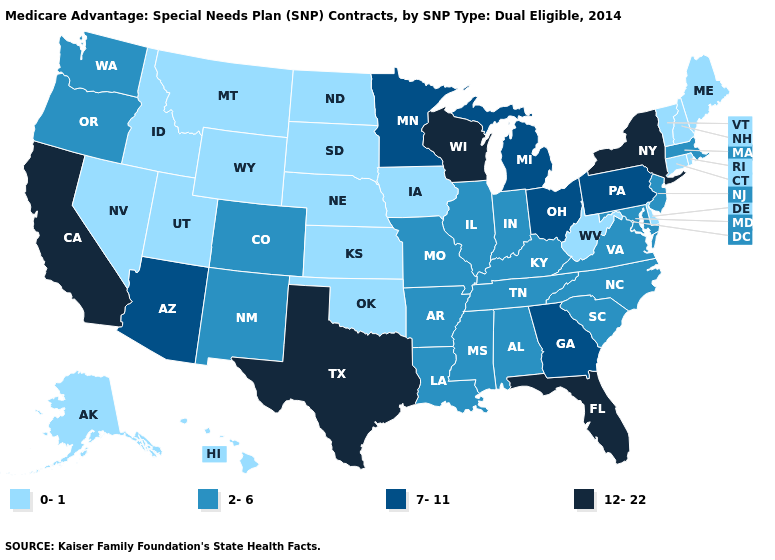Does Idaho have the lowest value in the West?
Quick response, please. Yes. Which states hav the highest value in the MidWest?
Write a very short answer. Wisconsin. What is the lowest value in states that border Connecticut?
Give a very brief answer. 0-1. What is the value of West Virginia?
Answer briefly. 0-1. What is the lowest value in states that border Washington?
Give a very brief answer. 0-1. Does North Dakota have the lowest value in the USA?
Answer briefly. Yes. Which states hav the highest value in the Northeast?
Keep it brief. New York. What is the value of Kansas?
Be succinct. 0-1. What is the value of Massachusetts?
Answer briefly. 2-6. Does Oklahoma have the lowest value in the South?
Short answer required. Yes. Does Texas have the highest value in the USA?
Quick response, please. Yes. What is the highest value in the South ?
Write a very short answer. 12-22. Does West Virginia have a lower value than Maine?
Give a very brief answer. No. Name the states that have a value in the range 12-22?
Concise answer only. California, Florida, New York, Texas, Wisconsin. How many symbols are there in the legend?
Be succinct. 4. 